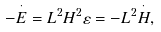Convert formula to latex. <formula><loc_0><loc_0><loc_500><loc_500>- \overset { \cdot } { E } = L ^ { 2 } H ^ { 2 } \varepsilon = - L ^ { 2 } \overset { \cdot } { H } ,</formula> 